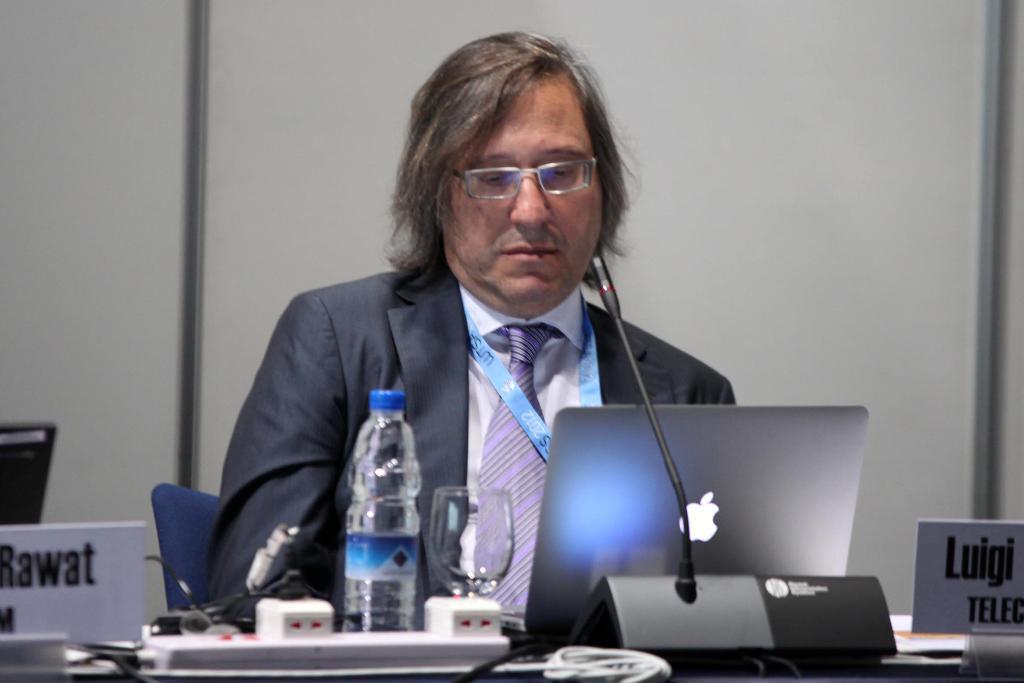In one or two sentences, can you explain what this image depicts? There is a person wearing a spectacle and sitting on a chair in front of the table on which, there is a laptop, a mic, bottle, name boards, glass and other objects. In the background, there is white wall. 